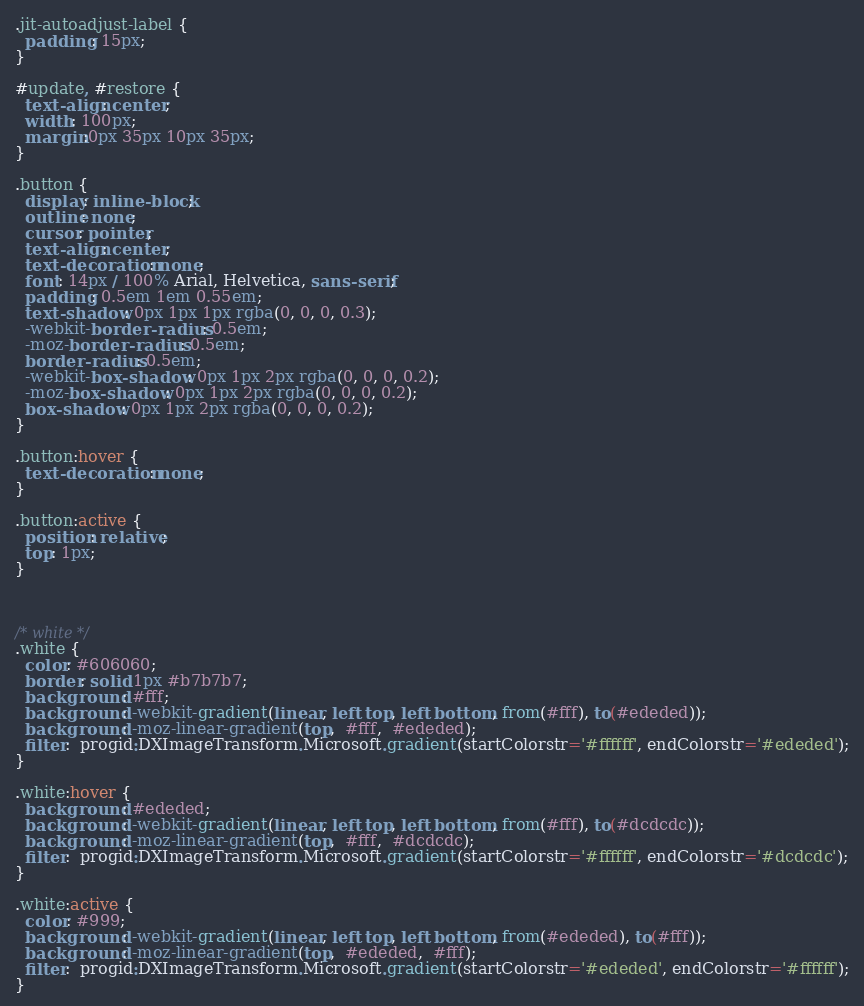Convert code to text. <code><loc_0><loc_0><loc_500><loc_500><_CSS_>.jit-autoadjust-label {
  padding: 15px;
}

#update, #restore {
  text-align: center;
  width: 100px;
  margin:0px 35px 10px 35px;
}

.button {
  display: inline-block;
  outline: none;
  cursor: pointer;
  text-align: center;
  text-decoration: none;
  font: 14px / 100% Arial, Helvetica, sans-serif;
  padding: 0.5em 1em 0.55em;
  text-shadow: 0px 1px 1px rgba(0, 0, 0, 0.3);
  -webkit-border-radius: 0.5em;
  -moz-border-radius: 0.5em;
  border-radius: 0.5em;
  -webkit-box-shadow: 0px 1px 2px rgba(0, 0, 0, 0.2);
  -moz-box-shadow: 0px 1px 2px rgba(0, 0, 0, 0.2);
  box-shadow: 0px 1px 2px rgba(0, 0, 0, 0.2);
}

.button:hover {
  text-decoration: none;
}

.button:active {
  position: relative;
  top: 1px;
}



/* white */
.white {
  color: #606060;
  border: solid 1px #b7b7b7;
  background: #fff;
  background: -webkit-gradient(linear, left top, left bottom, from(#fff), to(#ededed));
  background: -moz-linear-gradient(top,  #fff,  #ededed);
  filter:  progid:DXImageTransform.Microsoft.gradient(startColorstr='#ffffff', endColorstr='#ededed');
}

.white:hover {
  background: #ededed;
  background: -webkit-gradient(linear, left top, left bottom, from(#fff), to(#dcdcdc));
  background: -moz-linear-gradient(top,  #fff,  #dcdcdc);
  filter:  progid:DXImageTransform.Microsoft.gradient(startColorstr='#ffffff', endColorstr='#dcdcdc');
}

.white:active {
  color: #999;
  background: -webkit-gradient(linear, left top, left bottom, from(#ededed), to(#fff));
  background: -moz-linear-gradient(top,  #ededed,  #fff);
  filter:  progid:DXImageTransform.Microsoft.gradient(startColorstr='#ededed', endColorstr='#ffffff');
}
</code> 